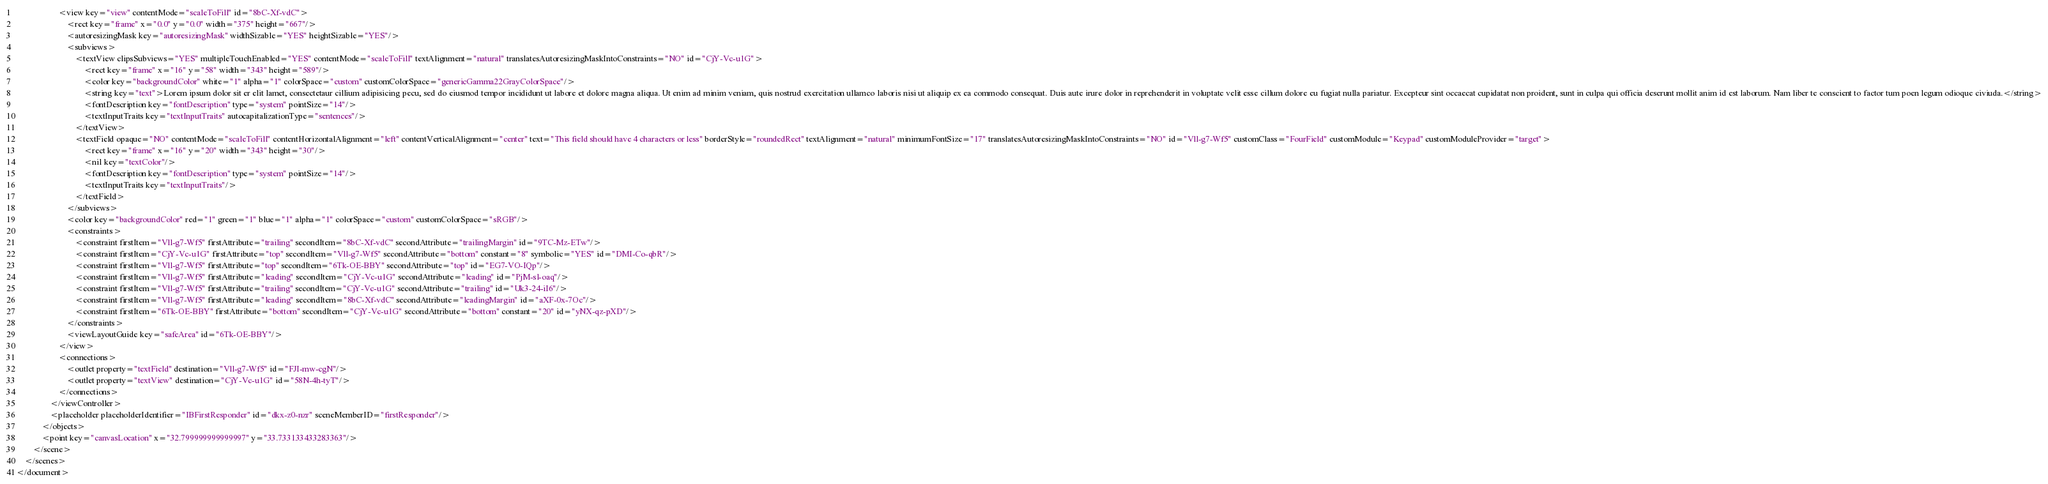Convert code to text. <code><loc_0><loc_0><loc_500><loc_500><_XML_>                    <view key="view" contentMode="scaleToFill" id="8bC-Xf-vdC">
                        <rect key="frame" x="0.0" y="0.0" width="375" height="667"/>
                        <autoresizingMask key="autoresizingMask" widthSizable="YES" heightSizable="YES"/>
                        <subviews>
                            <textView clipsSubviews="YES" multipleTouchEnabled="YES" contentMode="scaleToFill" textAlignment="natural" translatesAutoresizingMaskIntoConstraints="NO" id="CjY-Vc-u1G">
                                <rect key="frame" x="16" y="58" width="343" height="589"/>
                                <color key="backgroundColor" white="1" alpha="1" colorSpace="custom" customColorSpace="genericGamma22GrayColorSpace"/>
                                <string key="text">Lorem ipsum dolor sit er elit lamet, consectetaur cillium adipisicing pecu, sed do eiusmod tempor incididunt ut labore et dolore magna aliqua. Ut enim ad minim veniam, quis nostrud exercitation ullamco laboris nisi ut aliquip ex ea commodo consequat. Duis aute irure dolor in reprehenderit in voluptate velit esse cillum dolore eu fugiat nulla pariatur. Excepteur sint occaecat cupidatat non proident, sunt in culpa qui officia deserunt mollit anim id est laborum. Nam liber te conscient to factor tum poen legum odioque civiuda.</string>
                                <fontDescription key="fontDescription" type="system" pointSize="14"/>
                                <textInputTraits key="textInputTraits" autocapitalizationType="sentences"/>
                            </textView>
                            <textField opaque="NO" contentMode="scaleToFill" contentHorizontalAlignment="left" contentVerticalAlignment="center" text="This field should have 4 characters or less" borderStyle="roundedRect" textAlignment="natural" minimumFontSize="17" translatesAutoresizingMaskIntoConstraints="NO" id="Vll-g7-Wf5" customClass="FourField" customModule="Keypad" customModuleProvider="target">
                                <rect key="frame" x="16" y="20" width="343" height="30"/>
                                <nil key="textColor"/>
                                <fontDescription key="fontDescription" type="system" pointSize="14"/>
                                <textInputTraits key="textInputTraits"/>
                            </textField>
                        </subviews>
                        <color key="backgroundColor" red="1" green="1" blue="1" alpha="1" colorSpace="custom" customColorSpace="sRGB"/>
                        <constraints>
                            <constraint firstItem="Vll-g7-Wf5" firstAttribute="trailing" secondItem="8bC-Xf-vdC" secondAttribute="trailingMargin" id="9TC-Mz-ETw"/>
                            <constraint firstItem="CjY-Vc-u1G" firstAttribute="top" secondItem="Vll-g7-Wf5" secondAttribute="bottom" constant="8" symbolic="YES" id="DMI-Co-qbR"/>
                            <constraint firstItem="Vll-g7-Wf5" firstAttribute="top" secondItem="6Tk-OE-BBY" secondAttribute="top" id="EG7-VO-IQp"/>
                            <constraint firstItem="Vll-g7-Wf5" firstAttribute="leading" secondItem="CjY-Vc-u1G" secondAttribute="leading" id="PjM-sl-oaq"/>
                            <constraint firstItem="Vll-g7-Wf5" firstAttribute="trailing" secondItem="CjY-Vc-u1G" secondAttribute="trailing" id="Uk3-24-iI6"/>
                            <constraint firstItem="Vll-g7-Wf5" firstAttribute="leading" secondItem="8bC-Xf-vdC" secondAttribute="leadingMargin" id="aXF-0x-7Oc"/>
                            <constraint firstItem="6Tk-OE-BBY" firstAttribute="bottom" secondItem="CjY-Vc-u1G" secondAttribute="bottom" constant="20" id="yNX-qz-pXD"/>
                        </constraints>
                        <viewLayoutGuide key="safeArea" id="6Tk-OE-BBY"/>
                    </view>
                    <connections>
                        <outlet property="textField" destination="Vll-g7-Wf5" id="FJI-mw-cgN"/>
                        <outlet property="textView" destination="CjY-Vc-u1G" id="58N-4h-tyT"/>
                    </connections>
                </viewController>
                <placeholder placeholderIdentifier="IBFirstResponder" id="dkx-z0-nzr" sceneMemberID="firstResponder"/>
            </objects>
            <point key="canvasLocation" x="32.799999999999997" y="33.733133433283363"/>
        </scene>
    </scenes>
</document>
</code> 